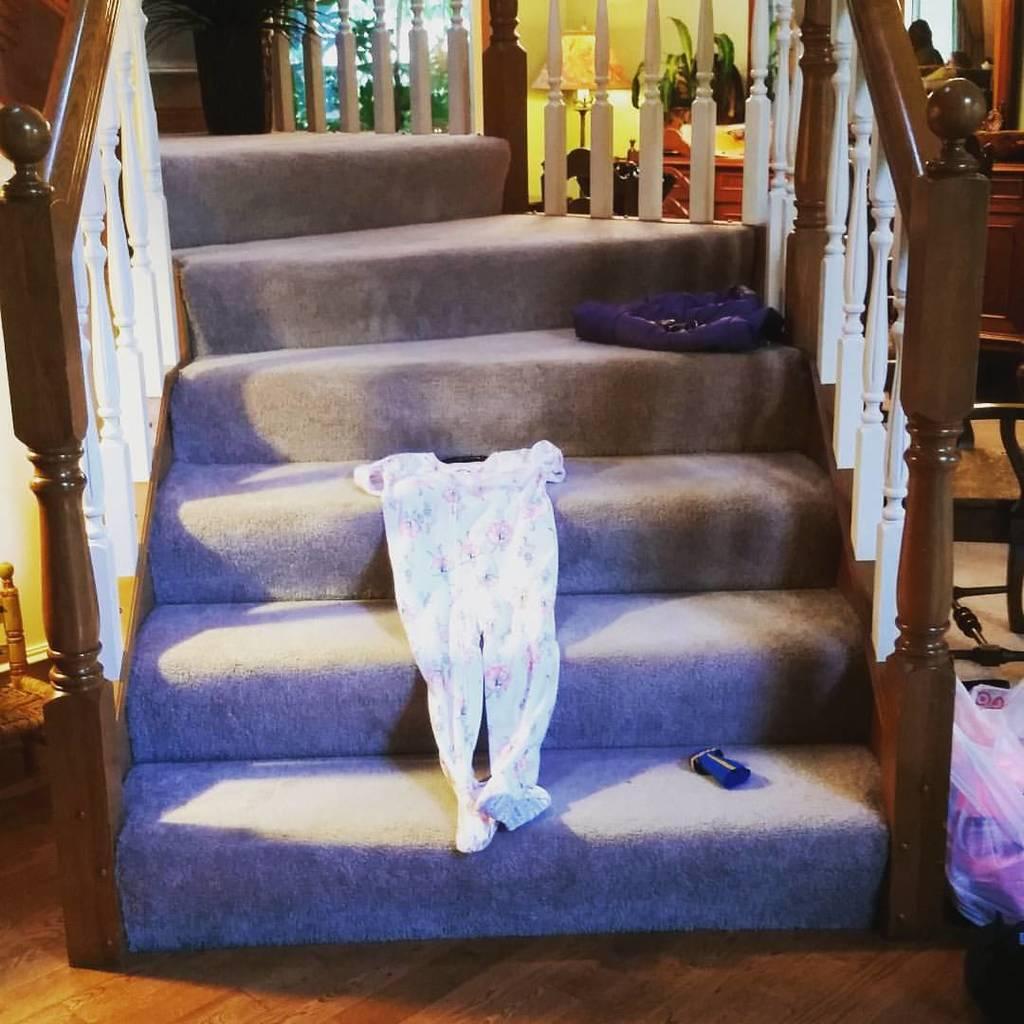Can you describe this image briefly? In this image I can see the railing which is brown and white in color, few stairs, a white colored dress and few blue colored objects on the stairs. I can see a plastic bag with few objects in it, the cream colored wall, a lamp, few plants and few other objects. 